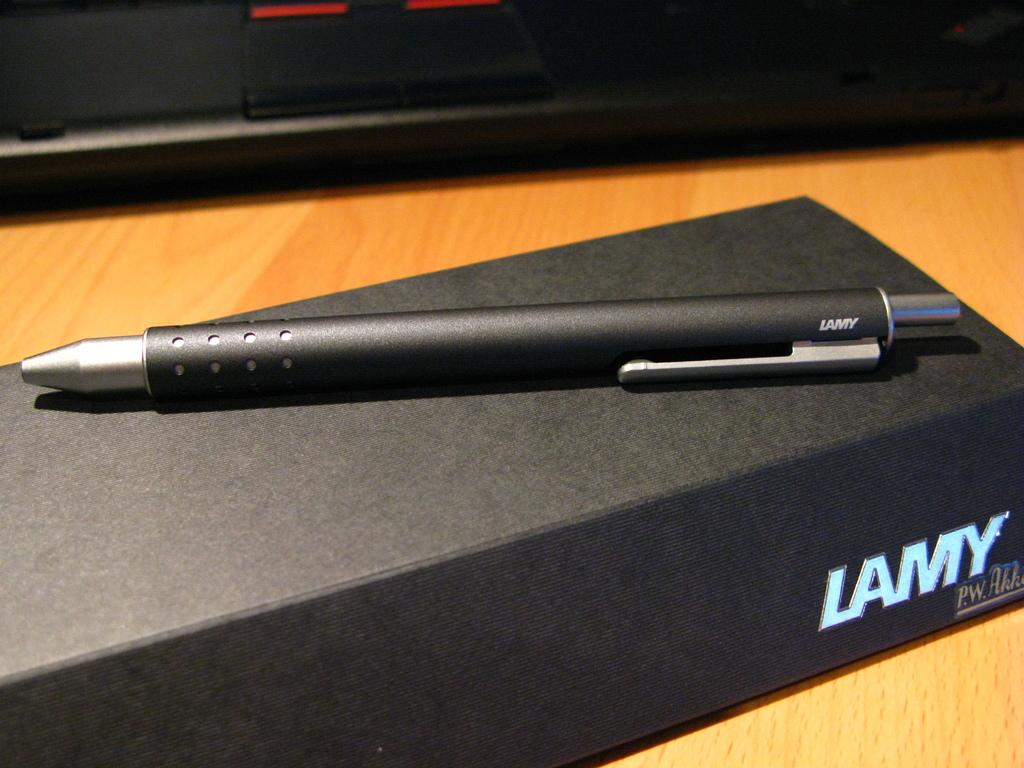What object is visible in the image? There is a pen in the image. Where is the pen placed? The pen is placed on a black box. What type of surface can be seen in the background of the image? There is a wooden surface in the background of the image. What color is the object at the top of the image? There is a black color object at the top of the image. How many lizards are crawling on the wooden surface in the image? There are no lizards present in the image; it only features a pen, a black box, and a wooden surface. What type of cream is being used to write with the pen in the image? There is no cream being used with the pen in the image; it is a regular pen. 